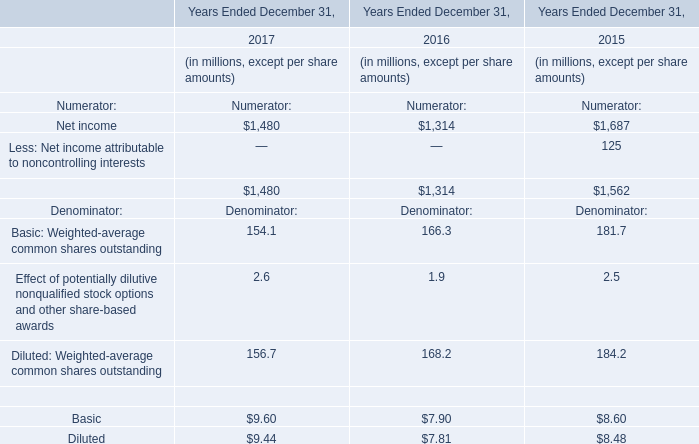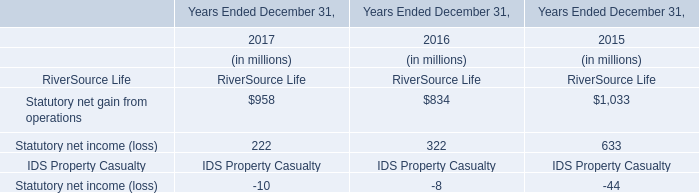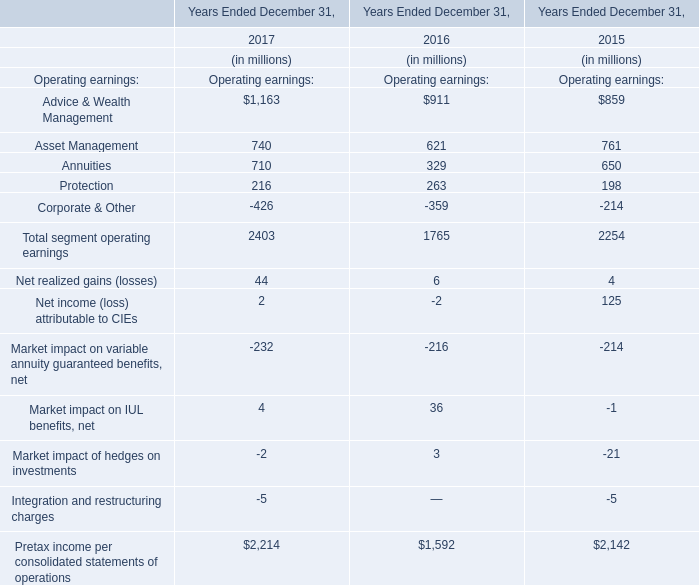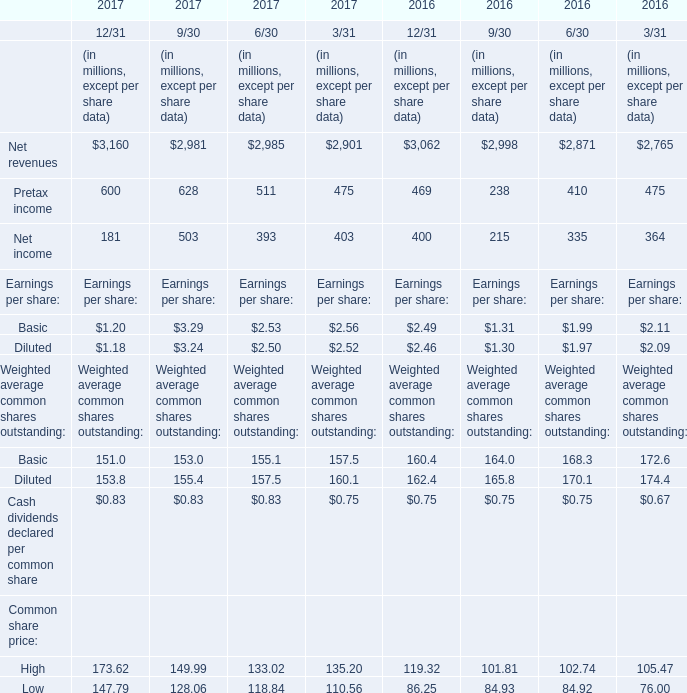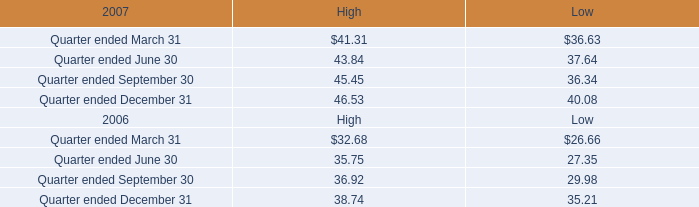In which year is Market impact of hedges on investments positive? 
Answer: 3. 